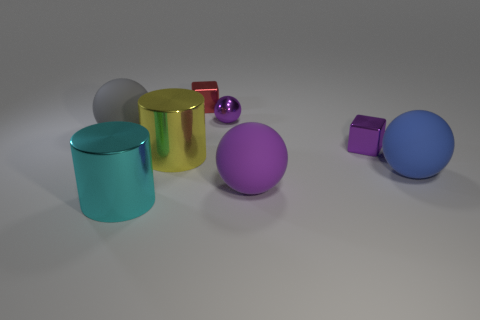Can you describe the arrangement and number of objects with regard to their colors and shapes? Certainly! In the image, there is an assortment of six objects with different colors and shapes. From the left, we have a matte grey cylinder, a shiny gold cylinder, a small shiny red sphere, a large matte purple sphere, a small matte red cube, and lastly, a large glossy blue sphere. 